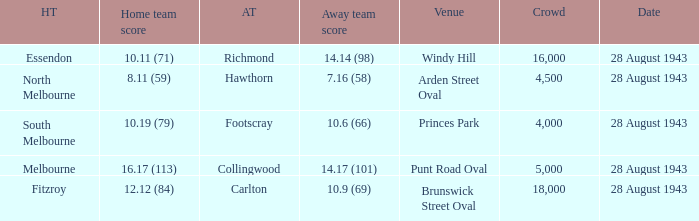Write the full table. {'header': ['HT', 'Home team score', 'AT', 'Away team score', 'Venue', 'Crowd', 'Date'], 'rows': [['Essendon', '10.11 (71)', 'Richmond', '14.14 (98)', 'Windy Hill', '16,000', '28 August 1943'], ['North Melbourne', '8.11 (59)', 'Hawthorn', '7.16 (58)', 'Arden Street Oval', '4,500', '28 August 1943'], ['South Melbourne', '10.19 (79)', 'Footscray', '10.6 (66)', 'Princes Park', '4,000', '28 August 1943'], ['Melbourne', '16.17 (113)', 'Collingwood', '14.17 (101)', 'Punt Road Oval', '5,000', '28 August 1943'], ['Fitzroy', '12.12 (84)', 'Carlton', '10.9 (69)', 'Brunswick Street Oval', '18,000', '28 August 1943']]} What game showed a home team score of 8.11 (59)? 28 August 1943. 